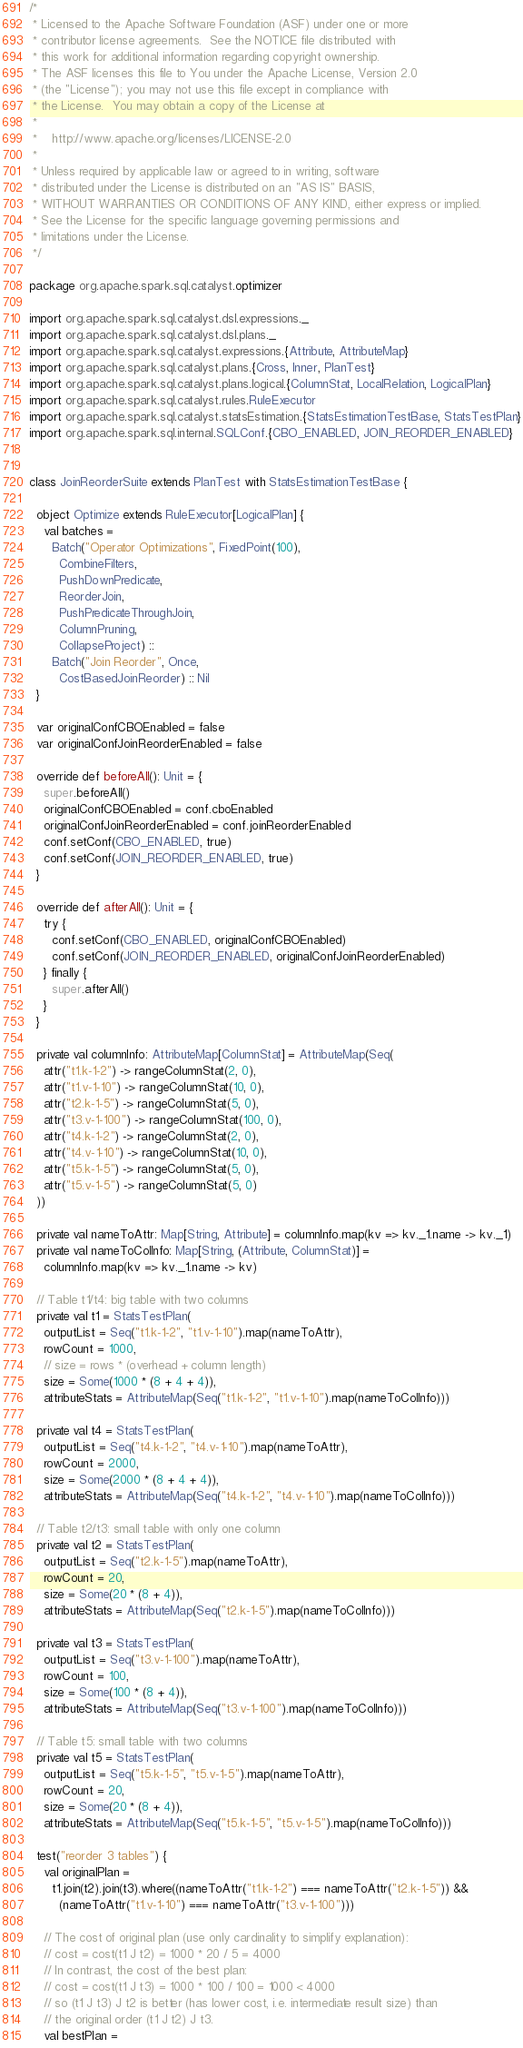Convert code to text. <code><loc_0><loc_0><loc_500><loc_500><_Scala_>/*
 * Licensed to the Apache Software Foundation (ASF) under one or more
 * contributor license agreements.  See the NOTICE file distributed with
 * this work for additional information regarding copyright ownership.
 * The ASF licenses this file to You under the Apache License, Version 2.0
 * (the "License"); you may not use this file except in compliance with
 * the License.  You may obtain a copy of the License at
 *
 *    http://www.apache.org/licenses/LICENSE-2.0
 *
 * Unless required by applicable law or agreed to in writing, software
 * distributed under the License is distributed on an "AS IS" BASIS,
 * WITHOUT WARRANTIES OR CONDITIONS OF ANY KIND, either express or implied.
 * See the License for the specific language governing permissions and
 * limitations under the License.
 */

package org.apache.spark.sql.catalyst.optimizer

import org.apache.spark.sql.catalyst.dsl.expressions._
import org.apache.spark.sql.catalyst.dsl.plans._
import org.apache.spark.sql.catalyst.expressions.{Attribute, AttributeMap}
import org.apache.spark.sql.catalyst.plans.{Cross, Inner, PlanTest}
import org.apache.spark.sql.catalyst.plans.logical.{ColumnStat, LocalRelation, LogicalPlan}
import org.apache.spark.sql.catalyst.rules.RuleExecutor
import org.apache.spark.sql.catalyst.statsEstimation.{StatsEstimationTestBase, StatsTestPlan}
import org.apache.spark.sql.internal.SQLConf.{CBO_ENABLED, JOIN_REORDER_ENABLED}


class JoinReorderSuite extends PlanTest with StatsEstimationTestBase {

  object Optimize extends RuleExecutor[LogicalPlan] {
    val batches =
      Batch("Operator Optimizations", FixedPoint(100),
        CombineFilters,
        PushDownPredicate,
        ReorderJoin,
        PushPredicateThroughJoin,
        ColumnPruning,
        CollapseProject) ::
      Batch("Join Reorder", Once,
        CostBasedJoinReorder) :: Nil
  }

  var originalConfCBOEnabled = false
  var originalConfJoinReorderEnabled = false

  override def beforeAll(): Unit = {
    super.beforeAll()
    originalConfCBOEnabled = conf.cboEnabled
    originalConfJoinReorderEnabled = conf.joinReorderEnabled
    conf.setConf(CBO_ENABLED, true)
    conf.setConf(JOIN_REORDER_ENABLED, true)
  }

  override def afterAll(): Unit = {
    try {
      conf.setConf(CBO_ENABLED, originalConfCBOEnabled)
      conf.setConf(JOIN_REORDER_ENABLED, originalConfJoinReorderEnabled)
    } finally {
      super.afterAll()
    }
  }

  private val columnInfo: AttributeMap[ColumnStat] = AttributeMap(Seq(
    attr("t1.k-1-2") -> rangeColumnStat(2, 0),
    attr("t1.v-1-10") -> rangeColumnStat(10, 0),
    attr("t2.k-1-5") -> rangeColumnStat(5, 0),
    attr("t3.v-1-100") -> rangeColumnStat(100, 0),
    attr("t4.k-1-2") -> rangeColumnStat(2, 0),
    attr("t4.v-1-10") -> rangeColumnStat(10, 0),
    attr("t5.k-1-5") -> rangeColumnStat(5, 0),
    attr("t5.v-1-5") -> rangeColumnStat(5, 0)
  ))

  private val nameToAttr: Map[String, Attribute] = columnInfo.map(kv => kv._1.name -> kv._1)
  private val nameToColInfo: Map[String, (Attribute, ColumnStat)] =
    columnInfo.map(kv => kv._1.name -> kv)

  // Table t1/t4: big table with two columns
  private val t1 = StatsTestPlan(
    outputList = Seq("t1.k-1-2", "t1.v-1-10").map(nameToAttr),
    rowCount = 1000,
    // size = rows * (overhead + column length)
    size = Some(1000 * (8 + 4 + 4)),
    attributeStats = AttributeMap(Seq("t1.k-1-2", "t1.v-1-10").map(nameToColInfo)))

  private val t4 = StatsTestPlan(
    outputList = Seq("t4.k-1-2", "t4.v-1-10").map(nameToAttr),
    rowCount = 2000,
    size = Some(2000 * (8 + 4 + 4)),
    attributeStats = AttributeMap(Seq("t4.k-1-2", "t4.v-1-10").map(nameToColInfo)))

  // Table t2/t3: small table with only one column
  private val t2 = StatsTestPlan(
    outputList = Seq("t2.k-1-5").map(nameToAttr),
    rowCount = 20,
    size = Some(20 * (8 + 4)),
    attributeStats = AttributeMap(Seq("t2.k-1-5").map(nameToColInfo)))

  private val t3 = StatsTestPlan(
    outputList = Seq("t3.v-1-100").map(nameToAttr),
    rowCount = 100,
    size = Some(100 * (8 + 4)),
    attributeStats = AttributeMap(Seq("t3.v-1-100").map(nameToColInfo)))

  // Table t5: small table with two columns
  private val t5 = StatsTestPlan(
    outputList = Seq("t5.k-1-5", "t5.v-1-5").map(nameToAttr),
    rowCount = 20,
    size = Some(20 * (8 + 4)),
    attributeStats = AttributeMap(Seq("t5.k-1-5", "t5.v-1-5").map(nameToColInfo)))

  test("reorder 3 tables") {
    val originalPlan =
      t1.join(t2).join(t3).where((nameToAttr("t1.k-1-2") === nameToAttr("t2.k-1-5")) &&
        (nameToAttr("t1.v-1-10") === nameToAttr("t3.v-1-100")))

    // The cost of original plan (use only cardinality to simplify explanation):
    // cost = cost(t1 J t2) = 1000 * 20 / 5 = 4000
    // In contrast, the cost of the best plan:
    // cost = cost(t1 J t3) = 1000 * 100 / 100 = 1000 < 4000
    // so (t1 J t3) J t2 is better (has lower cost, i.e. intermediate result size) than
    // the original order (t1 J t2) J t3.
    val bestPlan =</code> 